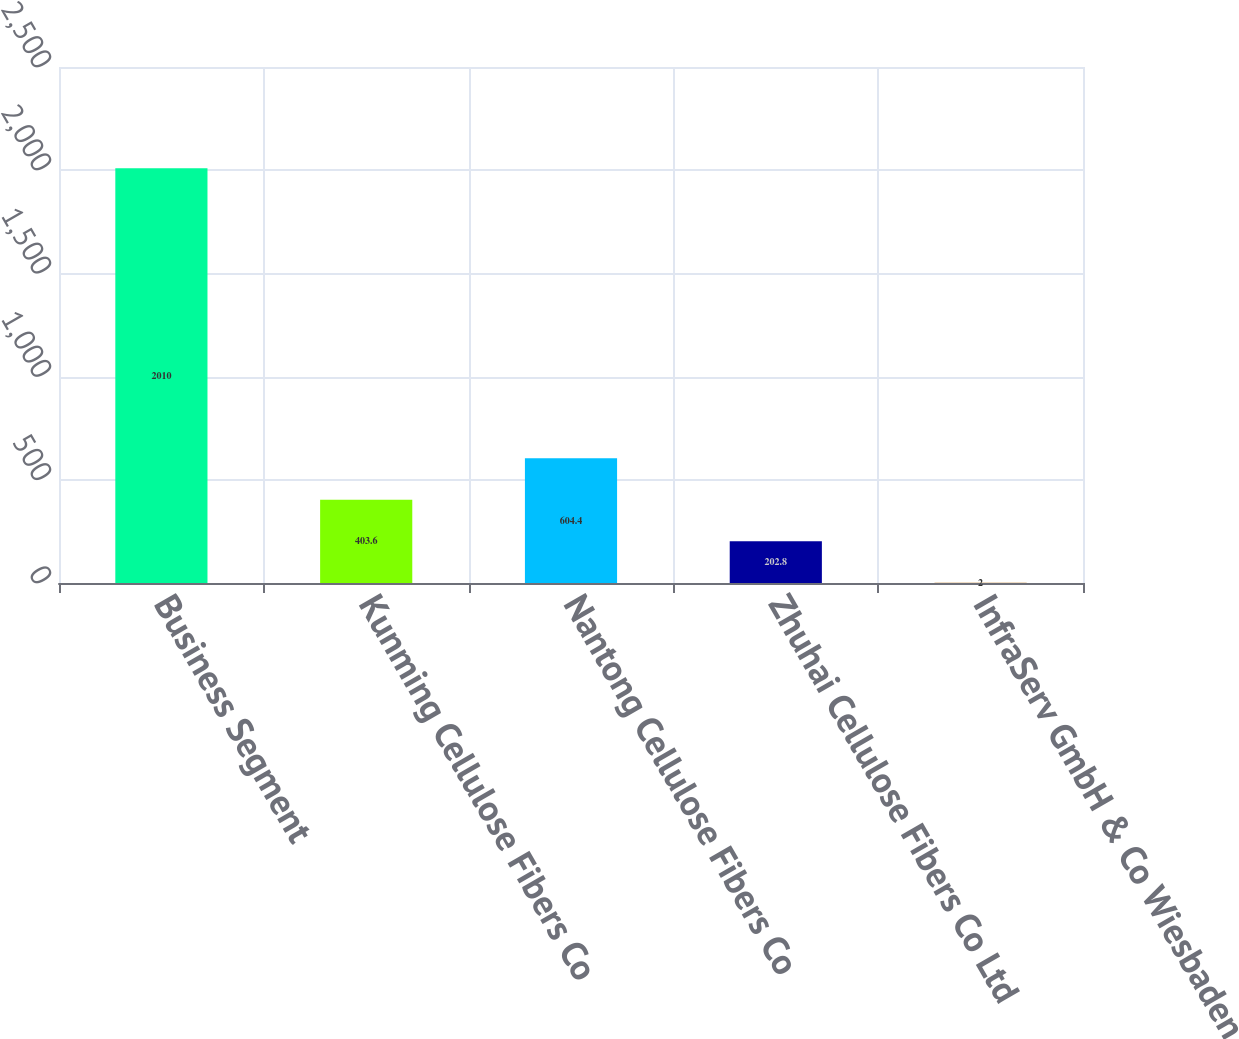Convert chart to OTSL. <chart><loc_0><loc_0><loc_500><loc_500><bar_chart><fcel>Business Segment<fcel>Kunming Cellulose Fibers Co<fcel>Nantong Cellulose Fibers Co<fcel>Zhuhai Cellulose Fibers Co Ltd<fcel>InfraServ GmbH & Co Wiesbaden<nl><fcel>2010<fcel>403.6<fcel>604.4<fcel>202.8<fcel>2<nl></chart> 